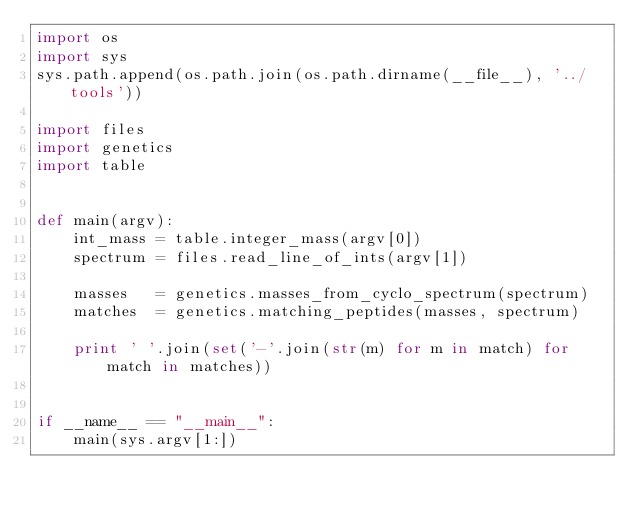<code> <loc_0><loc_0><loc_500><loc_500><_Python_>import os
import sys
sys.path.append(os.path.join(os.path.dirname(__file__), '../tools'))

import files
import genetics
import table


def main(argv):
    int_mass = table.integer_mass(argv[0])
    spectrum = files.read_line_of_ints(argv[1])

    masses   = genetics.masses_from_cyclo_spectrum(spectrum)
    matches  = genetics.matching_peptides(masses, spectrum)

    print ' '.join(set('-'.join(str(m) for m in match) for match in matches))


if __name__ == "__main__":
    main(sys.argv[1:])
</code> 